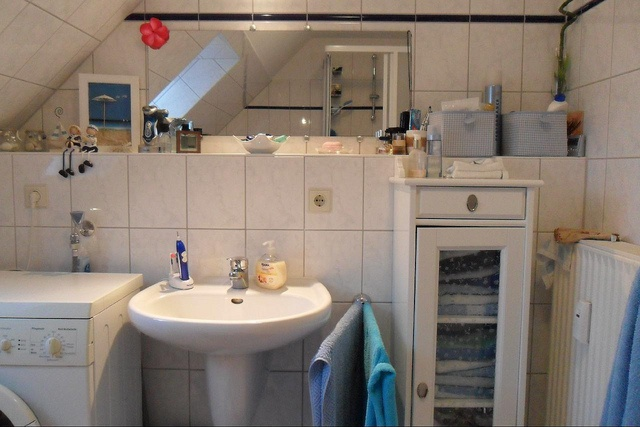Describe the objects in this image and their specific colors. I can see sink in gray, lightgray, darkgray, and tan tones, bottle in gray and tan tones, bottle in gray tones, bowl in gray and tan tones, and toothbrush in gray, navy, darkgray, and tan tones in this image. 